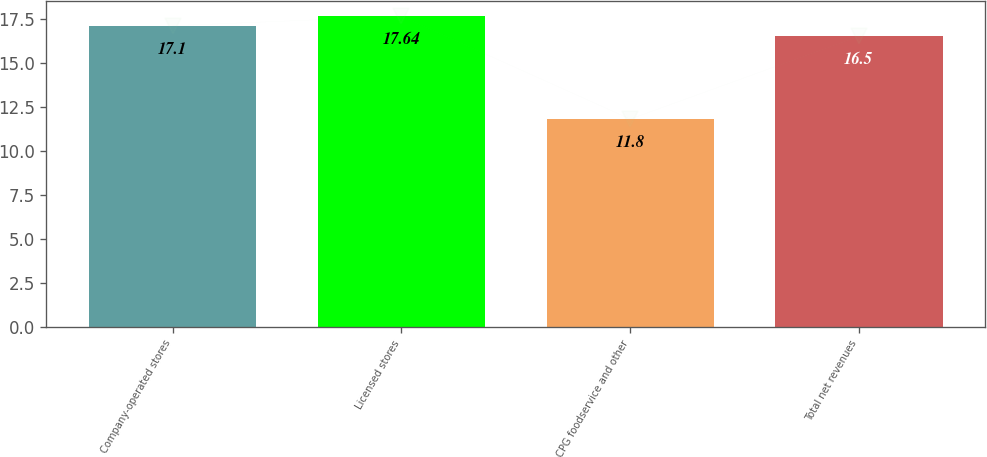Convert chart to OTSL. <chart><loc_0><loc_0><loc_500><loc_500><bar_chart><fcel>Company-operated stores<fcel>Licensed stores<fcel>CPG foodservice and other<fcel>Total net revenues<nl><fcel>17.1<fcel>17.64<fcel>11.8<fcel>16.5<nl></chart> 